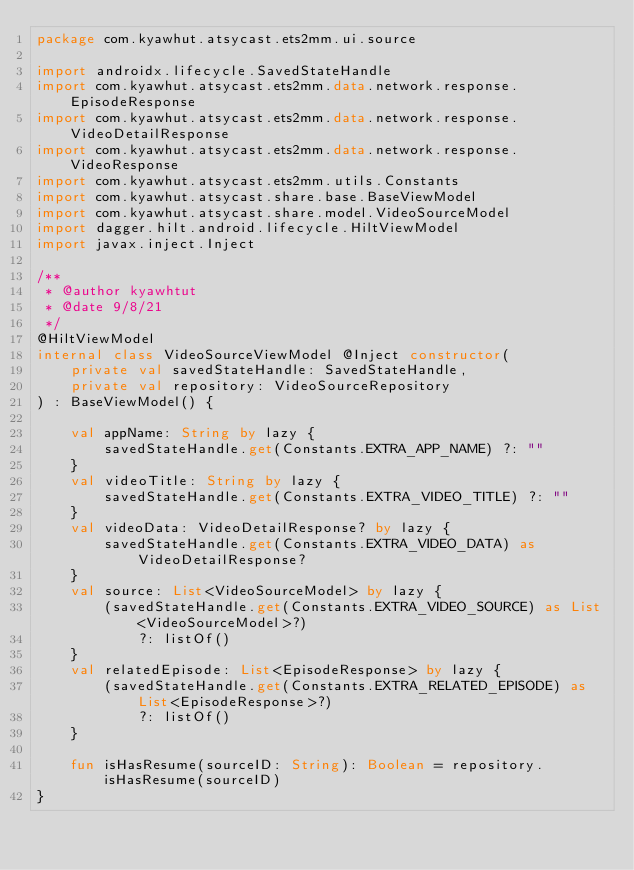Convert code to text. <code><loc_0><loc_0><loc_500><loc_500><_Kotlin_>package com.kyawhut.atsycast.ets2mm.ui.source

import androidx.lifecycle.SavedStateHandle
import com.kyawhut.atsycast.ets2mm.data.network.response.EpisodeResponse
import com.kyawhut.atsycast.ets2mm.data.network.response.VideoDetailResponse
import com.kyawhut.atsycast.ets2mm.data.network.response.VideoResponse
import com.kyawhut.atsycast.ets2mm.utils.Constants
import com.kyawhut.atsycast.share.base.BaseViewModel
import com.kyawhut.atsycast.share.model.VideoSourceModel
import dagger.hilt.android.lifecycle.HiltViewModel
import javax.inject.Inject

/**
 * @author kyawhtut
 * @date 9/8/21
 */
@HiltViewModel
internal class VideoSourceViewModel @Inject constructor(
    private val savedStateHandle: SavedStateHandle,
    private val repository: VideoSourceRepository
) : BaseViewModel() {

    val appName: String by lazy {
        savedStateHandle.get(Constants.EXTRA_APP_NAME) ?: ""
    }
    val videoTitle: String by lazy {
        savedStateHandle.get(Constants.EXTRA_VIDEO_TITLE) ?: ""
    }
    val videoData: VideoDetailResponse? by lazy {
        savedStateHandle.get(Constants.EXTRA_VIDEO_DATA) as VideoDetailResponse?
    }
    val source: List<VideoSourceModel> by lazy {
        (savedStateHandle.get(Constants.EXTRA_VIDEO_SOURCE) as List<VideoSourceModel>?)
            ?: listOf()
    }
    val relatedEpisode: List<EpisodeResponse> by lazy {
        (savedStateHandle.get(Constants.EXTRA_RELATED_EPISODE) as List<EpisodeResponse>?)
            ?: listOf()
    }

    fun isHasResume(sourceID: String): Boolean = repository.isHasResume(sourceID)
}
</code> 